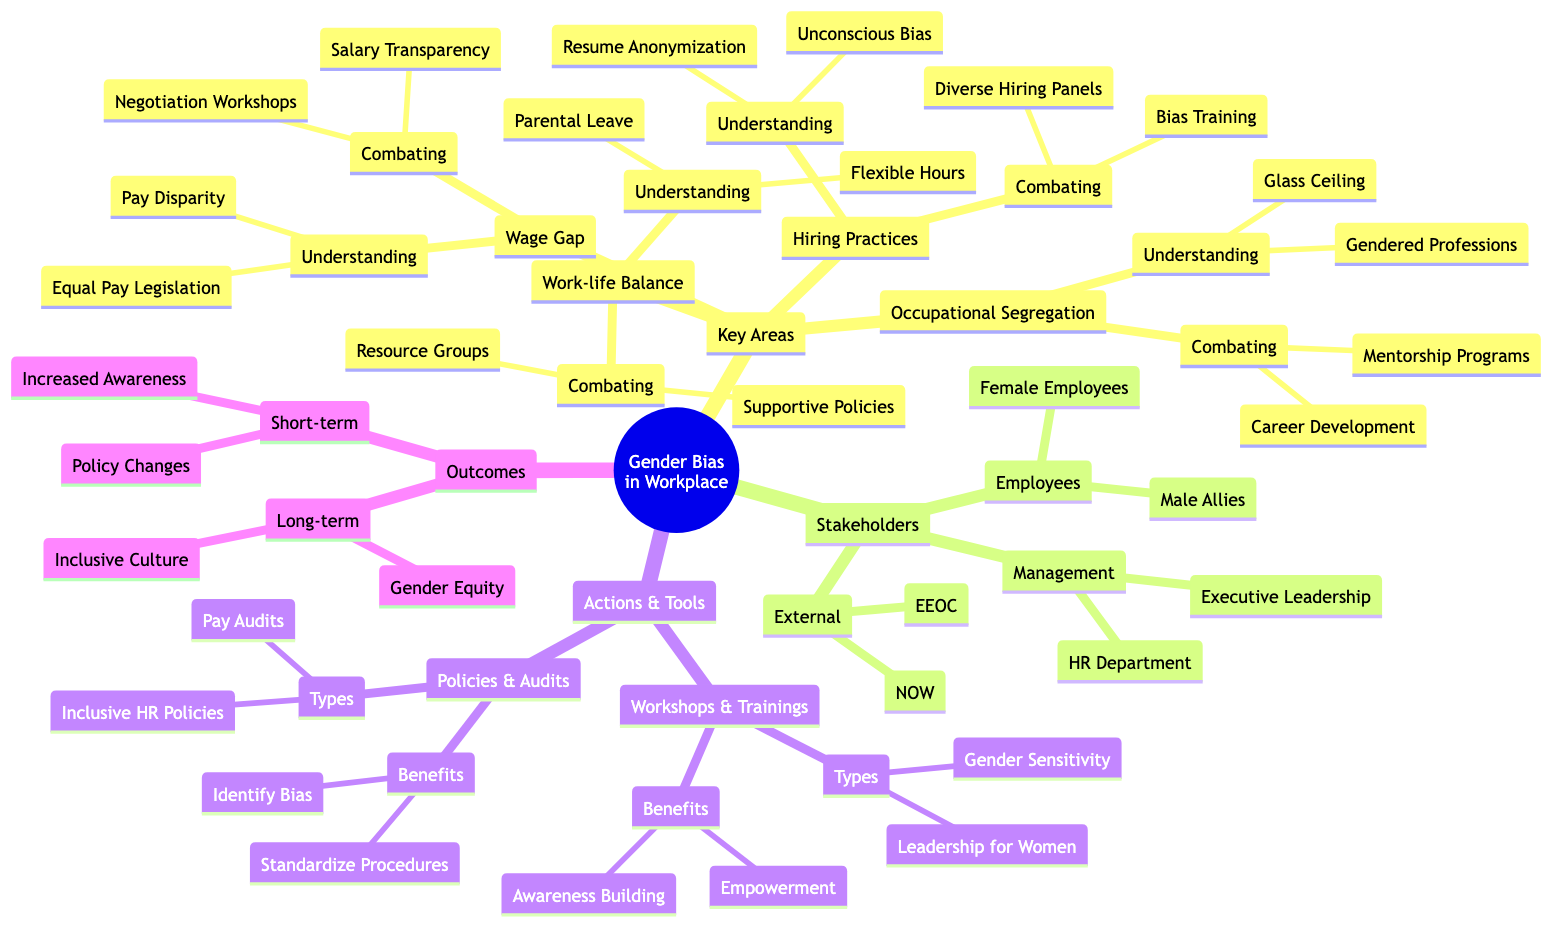what are the key areas of gender bias in the workplace? The diagram lists four main key areas: Wage Gap, Hiring Practices, Occupational Segregation, and Work-life Balance. These are clearly marked as the primary components of the structure.
Answer: Wage Gap, Hiring Practices, Occupational Segregation, Work-life Balance how many stakeholders are identified in the diagram? The diagram outlines three groups of stakeholders: Employees, Management, and External Organizations. Each group contains specific entities, but the total groups are three.
Answer: 3 what is one combating strategy for the wage gap? Under the Wage Gap section, one of the combating strategies listed is Salary Transparency. This is explicitly mentioned in the combating strategies for the wage gap.
Answer: Salary Transparency which stakeholder group includes male allies? The diagram specifies that male allies are part of the Employees group under Stakeholders. This means they are categorized within the employees' stakeholders in the workplace.
Answer: Employees what are the benefits of workshops and trainings listed? The diagram states two benefits for Workshops and Trainings in the Actions and Tools section: Awareness Building and Empowerment. These are directly identified as benefits.
Answer: Awareness Building, Empowerment name one understanding issue related to hiring practices. Under the Hiring Practices key area, one understanding issue is Unconscious Bias. This is directly stated under the understanding section for hiring practices.
Answer: Unconscious Bias how many types of policies and audits are mentioned? The diagram lists two types under Policies and Audits: Annual Pay Audits and Inclusive HR Policies. Counting these gives us the total mentioned.
Answer: 2 what is the expected long-term outcome of combating gender bias? The diagram mentions Gender Equity and Inclusive Workplace Culture as the long-term outcomes, indicating what can be expected after addressing gender bias effectively.
Answer: Gender Equity, Inclusive Workplace Culture 